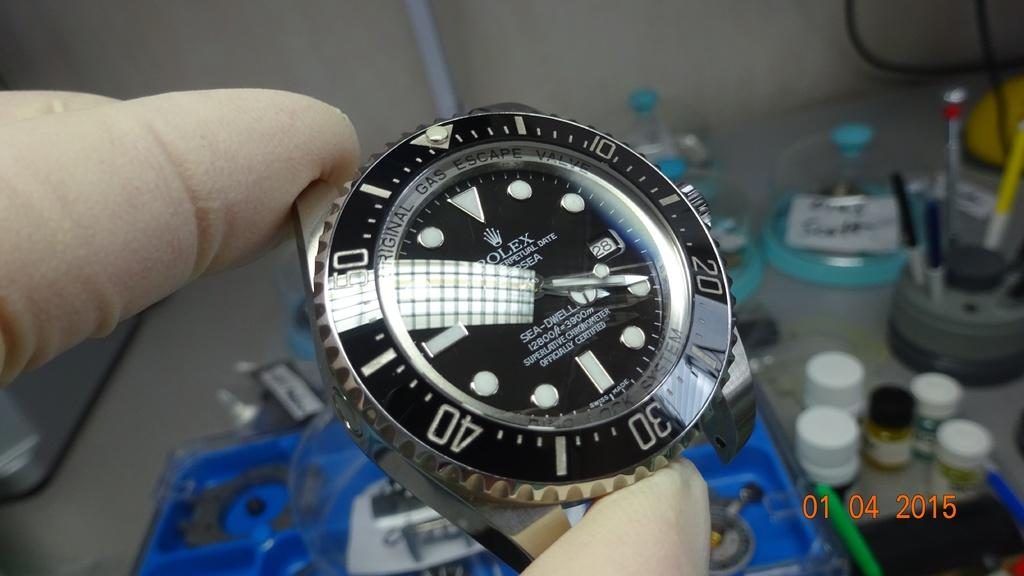<image>
Write a terse but informative summary of the picture. Someone wearing white gloves is holding up a Rolex watch. 